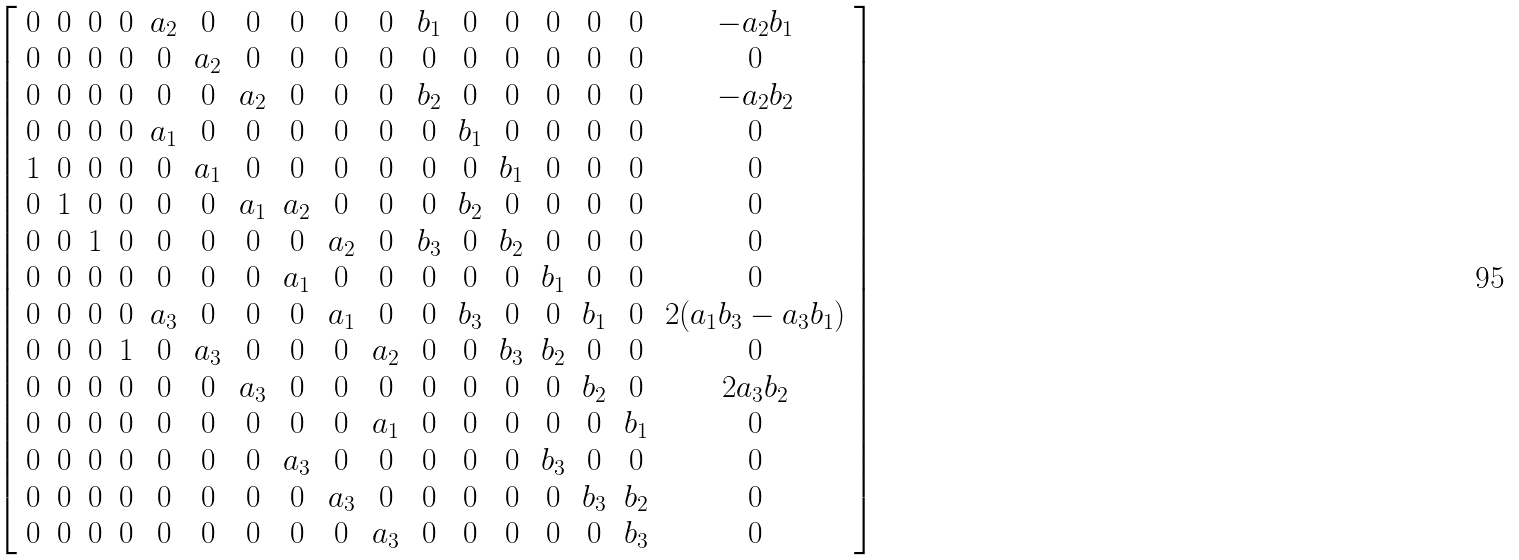Convert formula to latex. <formula><loc_0><loc_0><loc_500><loc_500>\left [ { \begin{array} { r r r r c c c c c c c c c c c c c } 0 & 0 & 0 & 0 & { a _ { 2 } } & 0 & 0 & 0 & 0 & 0 & { b _ { 1 } } & 0 & 0 & 0 & 0 & 0 & - { a _ { 2 } } { b _ { 1 } } \\ 0 & 0 & 0 & 0 & 0 & { a _ { 2 } } & 0 & 0 & 0 & 0 & 0 & 0 & 0 & 0 & 0 & 0 & 0 \\ 0 & 0 & 0 & 0 & 0 & 0 & { a _ { 2 } } & 0 & 0 & 0 & { b _ { 2 } } & 0 & 0 & 0 & 0 & 0 & - { a _ { 2 } } { b _ { 2 } } \\ 0 & 0 & 0 & 0 & { a _ { 1 } } & 0 & 0 & 0 & 0 & 0 & 0 & { b _ { 1 } } & 0 & 0 & 0 & 0 & 0 \\ 1 & 0 & 0 & 0 & 0 & { a _ { 1 } } & 0 & 0 & 0 & 0 & 0 & 0 & { b _ { 1 } } & 0 & 0 & 0 & 0 \\ 0 & 1 & 0 & 0 & 0 & 0 & { a _ { 1 } } & { a _ { 2 } } & 0 & 0 & 0 & { b _ { 2 } } & 0 & 0 & 0 & 0 & 0 \\ 0 & 0 & 1 & 0 & 0 & 0 & 0 & 0 & { a _ { 2 } } & 0 & { b _ { 3 } } & 0 & { b _ { 2 } } & 0 & 0 & 0 & 0 \\ 0 & 0 & 0 & 0 & 0 & 0 & 0 & { a _ { 1 } } & 0 & 0 & 0 & 0 & 0 & { b _ { 1 } } & 0 & 0 & 0 \\ 0 & 0 & 0 & 0 & { a _ { 3 } } & 0 & 0 & 0 & { a _ { 1 } } & 0 & 0 & { b _ { 3 } } & 0 & 0 & { b _ { 1 } } & 0 & 2 ( { a _ { 1 } } { b _ { 3 } } - { a _ { 3 } } { b _ { 1 } } ) \\ 0 & 0 & 0 & 1 & 0 & { a _ { 3 } } & 0 & 0 & 0 & { a _ { 2 } } & 0 & 0 & { b _ { 3 } } & { b _ { 2 } } & 0 & 0 & 0 \\ 0 & 0 & 0 & 0 & 0 & 0 & { a _ { 3 } } & 0 & 0 & 0 & 0 & 0 & 0 & 0 & { b _ { 2 } } & 0 & 2 { a _ { 3 } } { b _ { 2 } } \\ 0 & 0 & 0 & 0 & 0 & 0 & 0 & 0 & 0 & { a _ { 1 } } & 0 & 0 & 0 & 0 & 0 & { b _ { 1 } } & 0 \\ 0 & 0 & 0 & 0 & 0 & 0 & 0 & { a _ { 3 } } & 0 & 0 & 0 & 0 & 0 & { b _ { 3 } } & 0 & 0 & 0 \\ 0 & 0 & 0 & 0 & 0 & 0 & 0 & 0 & { a _ { 3 } } & 0 & 0 & 0 & 0 & 0 & { b _ { 3 } } & { b _ { 2 } } & 0 \\ 0 & 0 & 0 & 0 & 0 & 0 & 0 & 0 & 0 & { a _ { 3 } } & 0 & 0 & 0 & 0 & 0 & { b _ { 3 } } & 0 \end{array} } \right ]</formula> 